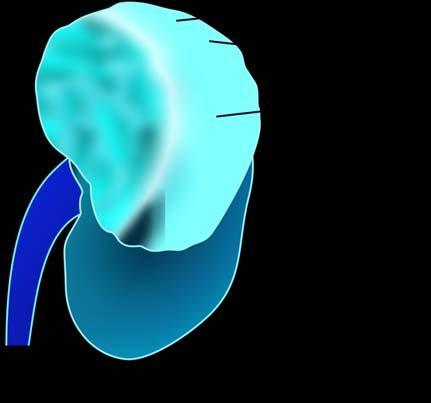what shows irregular, circumscribed, yellowish mass with areas of haemorrhages and necrosis?
Answer the question using a single word or phrase. Sectioned surface 